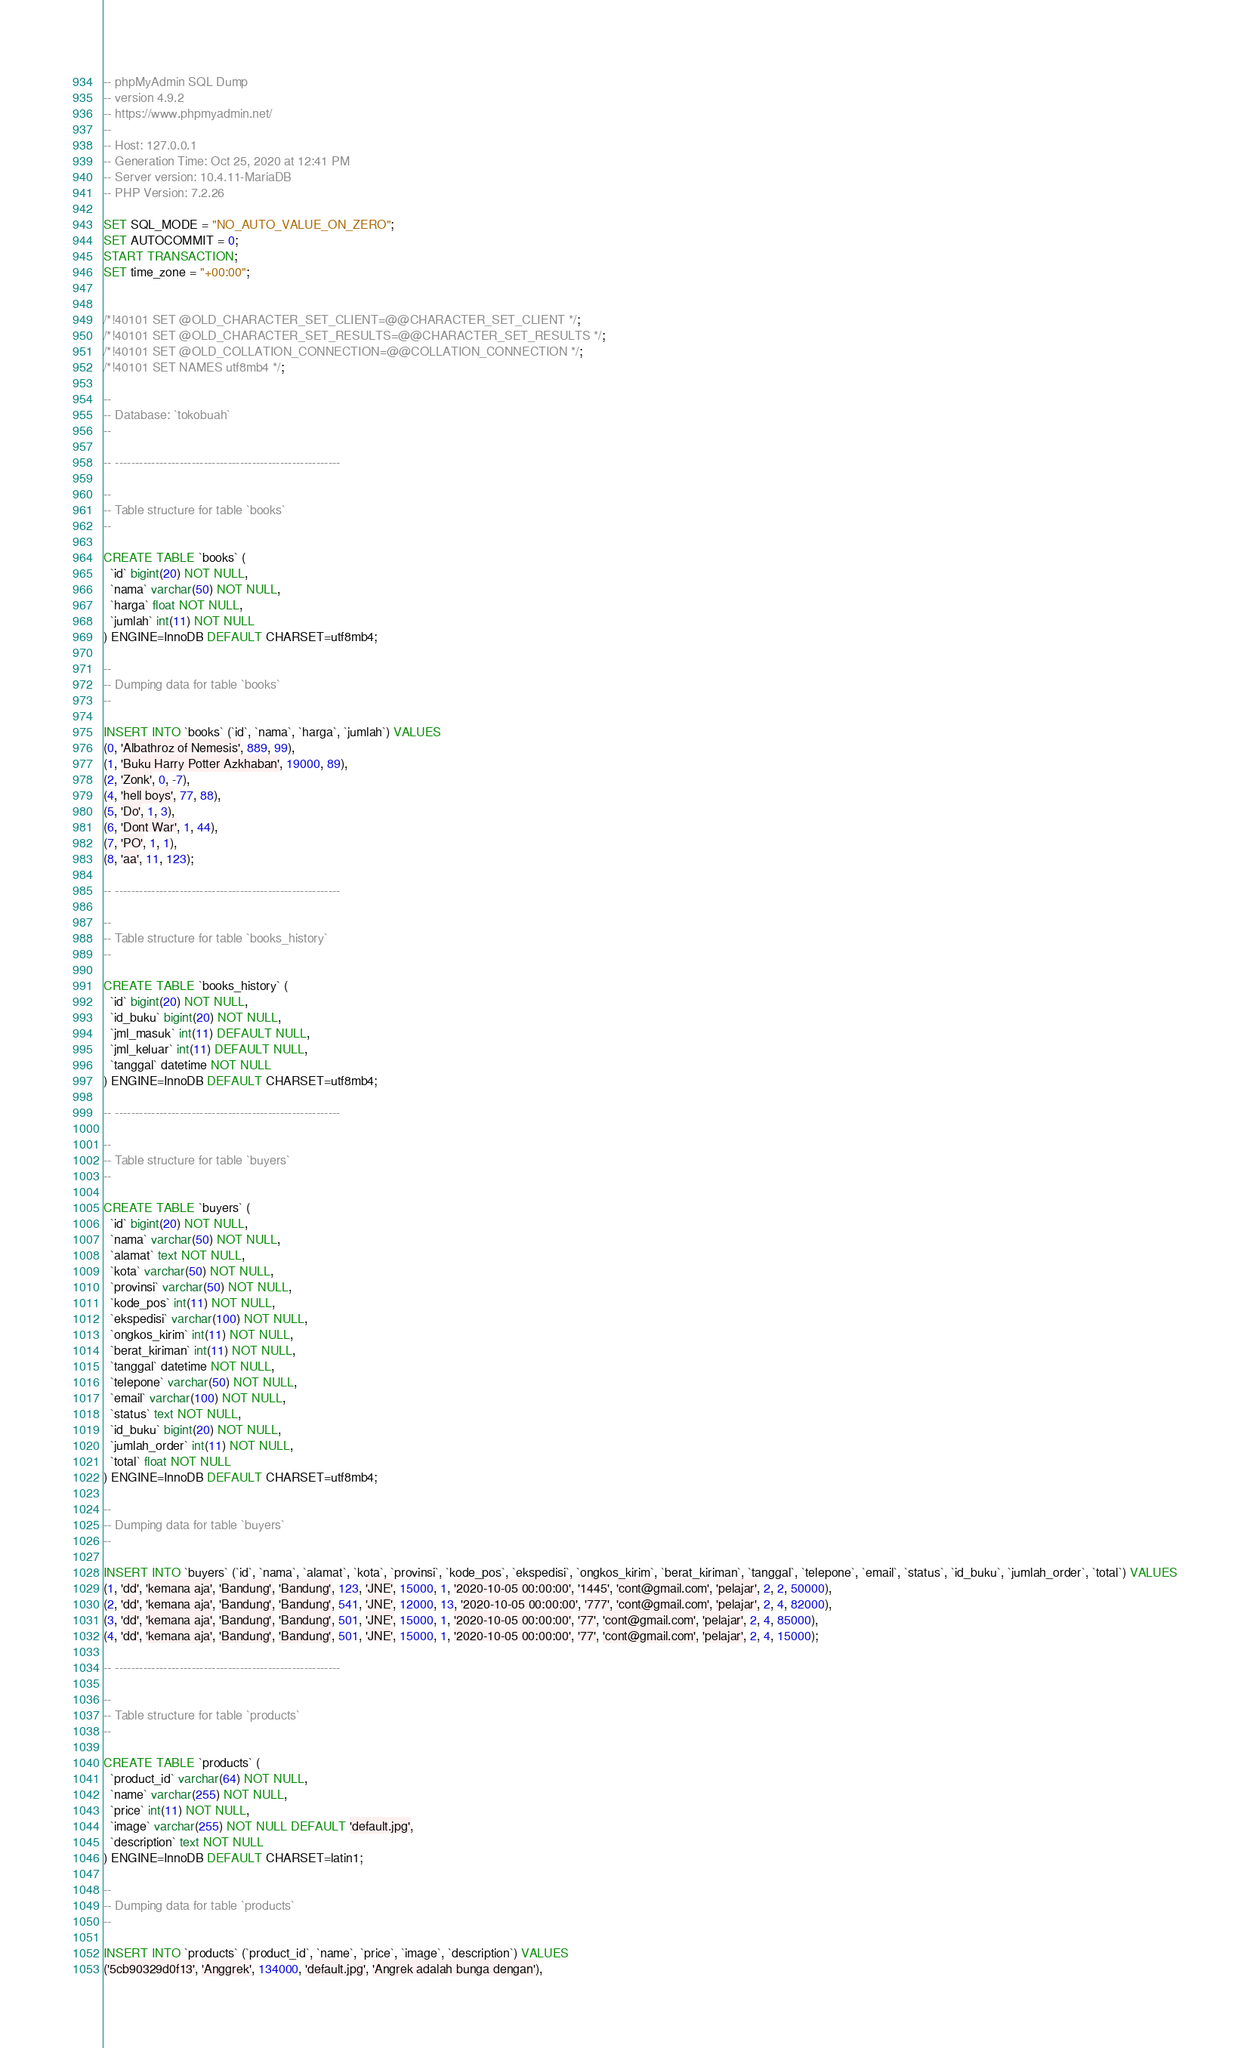<code> <loc_0><loc_0><loc_500><loc_500><_SQL_>-- phpMyAdmin SQL Dump
-- version 4.9.2
-- https://www.phpmyadmin.net/
--
-- Host: 127.0.0.1
-- Generation Time: Oct 25, 2020 at 12:41 PM
-- Server version: 10.4.11-MariaDB
-- PHP Version: 7.2.26

SET SQL_MODE = "NO_AUTO_VALUE_ON_ZERO";
SET AUTOCOMMIT = 0;
START TRANSACTION;
SET time_zone = "+00:00";


/*!40101 SET @OLD_CHARACTER_SET_CLIENT=@@CHARACTER_SET_CLIENT */;
/*!40101 SET @OLD_CHARACTER_SET_RESULTS=@@CHARACTER_SET_RESULTS */;
/*!40101 SET @OLD_COLLATION_CONNECTION=@@COLLATION_CONNECTION */;
/*!40101 SET NAMES utf8mb4 */;

--
-- Database: `tokobuah`
--

-- --------------------------------------------------------

--
-- Table structure for table `books`
--

CREATE TABLE `books` (
  `id` bigint(20) NOT NULL,
  `nama` varchar(50) NOT NULL,
  `harga` float NOT NULL,
  `jumlah` int(11) NOT NULL
) ENGINE=InnoDB DEFAULT CHARSET=utf8mb4;

--
-- Dumping data for table `books`
--

INSERT INTO `books` (`id`, `nama`, `harga`, `jumlah`) VALUES
(0, 'Albathroz of Nemesis', 889, 99),
(1, 'Buku Harry Potter Azkhaban', 19000, 89),
(2, 'Zonk', 0, -7),
(4, 'hell boys', 77, 88),
(5, 'Do', 1, 3),
(6, 'Dont War', 1, 44),
(7, 'PO', 1, 1),
(8, 'aa', 11, 123);

-- --------------------------------------------------------

--
-- Table structure for table `books_history`
--

CREATE TABLE `books_history` (
  `id` bigint(20) NOT NULL,
  `id_buku` bigint(20) NOT NULL,
  `jml_masuk` int(11) DEFAULT NULL,
  `jml_keluar` int(11) DEFAULT NULL,
  `tanggal` datetime NOT NULL
) ENGINE=InnoDB DEFAULT CHARSET=utf8mb4;

-- --------------------------------------------------------

--
-- Table structure for table `buyers`
--

CREATE TABLE `buyers` (
  `id` bigint(20) NOT NULL,
  `nama` varchar(50) NOT NULL,
  `alamat` text NOT NULL,
  `kota` varchar(50) NOT NULL,
  `provinsi` varchar(50) NOT NULL,
  `kode_pos` int(11) NOT NULL,
  `ekspedisi` varchar(100) NOT NULL,
  `ongkos_kirim` int(11) NOT NULL,
  `berat_kiriman` int(11) NOT NULL,
  `tanggal` datetime NOT NULL,
  `telepone` varchar(50) NOT NULL,
  `email` varchar(100) NOT NULL,
  `status` text NOT NULL,
  `id_buku` bigint(20) NOT NULL,
  `jumlah_order` int(11) NOT NULL,
  `total` float NOT NULL
) ENGINE=InnoDB DEFAULT CHARSET=utf8mb4;

--
-- Dumping data for table `buyers`
--

INSERT INTO `buyers` (`id`, `nama`, `alamat`, `kota`, `provinsi`, `kode_pos`, `ekspedisi`, `ongkos_kirim`, `berat_kiriman`, `tanggal`, `telepone`, `email`, `status`, `id_buku`, `jumlah_order`, `total`) VALUES
(1, 'dd', 'kemana aja', 'Bandung', 'Bandung', 123, 'JNE', 15000, 1, '2020-10-05 00:00:00', '1445', 'cont@gmail.com', 'pelajar', 2, 2, 50000),
(2, 'dd', 'kemana aja', 'Bandung', 'Bandung', 541, 'JNE', 12000, 13, '2020-10-05 00:00:00', '777', 'cont@gmail.com', 'pelajar', 2, 4, 82000),
(3, 'dd', 'kemana aja', 'Bandung', 'Bandung', 501, 'JNE', 15000, 1, '2020-10-05 00:00:00', '77', 'cont@gmail.com', 'pelajar', 2, 4, 85000),
(4, 'dd', 'kemana aja', 'Bandung', 'Bandung', 501, 'JNE', 15000, 1, '2020-10-05 00:00:00', '77', 'cont@gmail.com', 'pelajar', 2, 4, 15000);

-- --------------------------------------------------------

--
-- Table structure for table `products`
--

CREATE TABLE `products` (
  `product_id` varchar(64) NOT NULL,
  `name` varchar(255) NOT NULL,
  `price` int(11) NOT NULL,
  `image` varchar(255) NOT NULL DEFAULT 'default.jpg',
  `description` text NOT NULL
) ENGINE=InnoDB DEFAULT CHARSET=latin1;

--
-- Dumping data for table `products`
--

INSERT INTO `products` (`product_id`, `name`, `price`, `image`, `description`) VALUES
('5cb90329d0f13', 'Anggrek', 134000, 'default.jpg', 'Angrek adalah bunga dengan'),</code> 